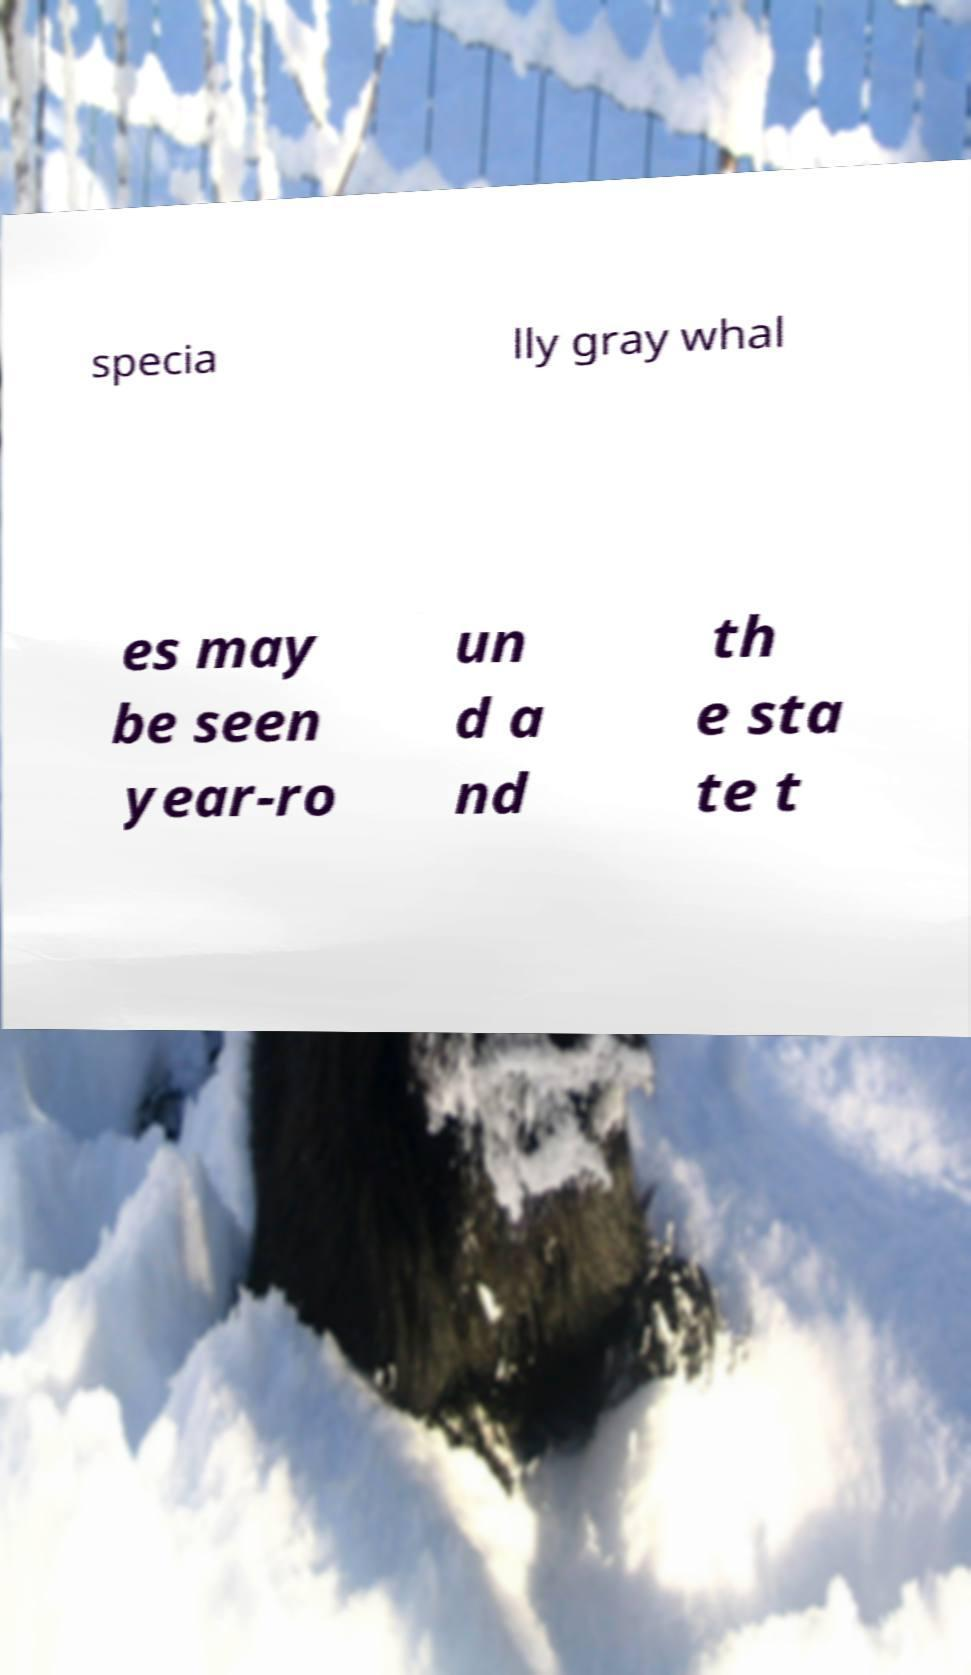For documentation purposes, I need the text within this image transcribed. Could you provide that? specia lly gray whal es may be seen year-ro un d a nd th e sta te t 